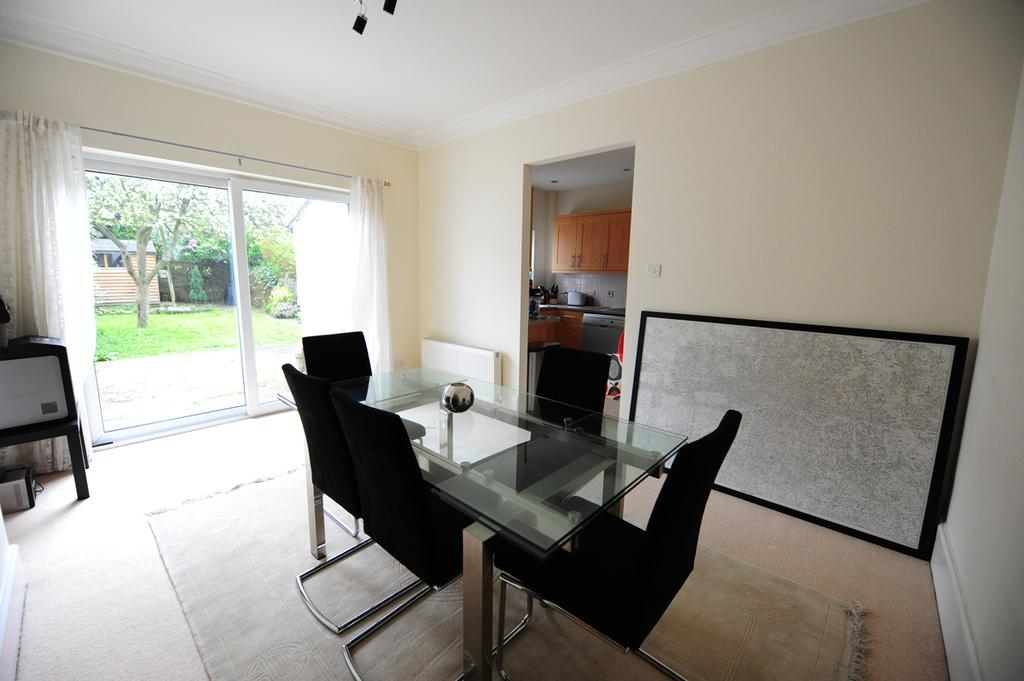What part of a building can be seen in the image? The image shows the inner part of a building. What type of furniture is present in the image? There are chairs and at least one table in the image. What objects can be seen in the image? There are objects in the image, including chairs, a table, and a cupboard. Where is the cupboard located in the image? The cupboard is in the image. What can be seen through the windows in the image? Trees are visible in the image through the windows. What type of window treatment is present in the image? There are curtains associated with the windows in the image. What type of lipstick is the fireman using in the image? There is no fireman or lipstick present in the image. What type of quiver is the person holding in the image? There is no person holding a quiver in the image. 